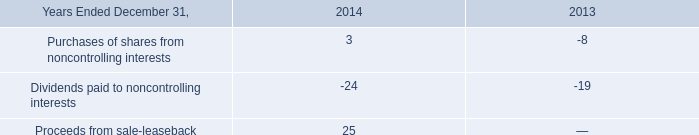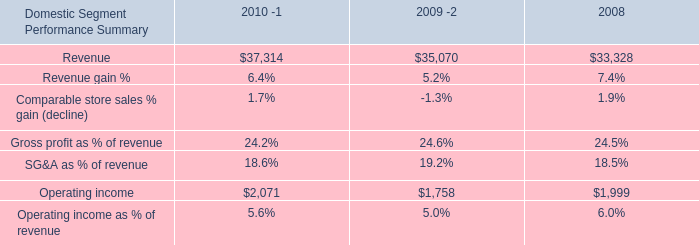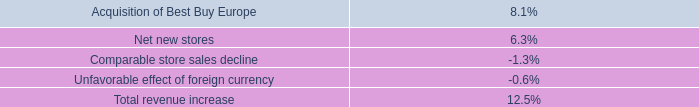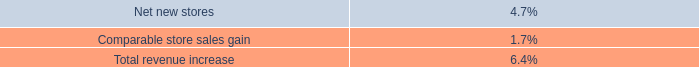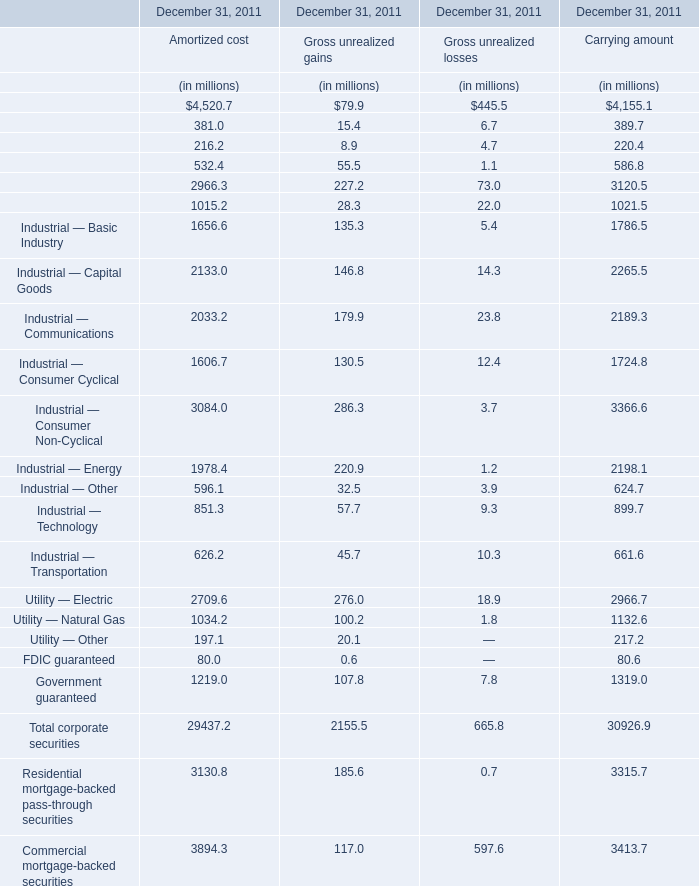what was the change in the long-term investments from 2014 to 2015 in millions 
Computations: (135 - 143)
Answer: -8.0. 